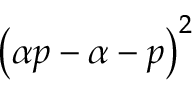<formula> <loc_0><loc_0><loc_500><loc_500>\left ( \alpha p - \alpha - p \right ) ^ { 2 }</formula> 